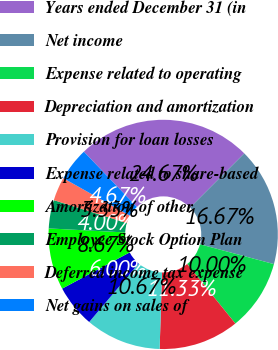Convert chart to OTSL. <chart><loc_0><loc_0><loc_500><loc_500><pie_chart><fcel>Years ended December 31 (in<fcel>Net income<fcel>Expense related to operating<fcel>Depreciation and amortization<fcel>Provision for loan losses<fcel>Expense related to share-based<fcel>Amortization of other<fcel>Employee Stock Option Plan<fcel>Deferred income tax expense<fcel>Net gains on sales of<nl><fcel>24.67%<fcel>16.67%<fcel>10.0%<fcel>11.33%<fcel>10.67%<fcel>6.0%<fcel>8.67%<fcel>4.0%<fcel>3.33%<fcel>4.67%<nl></chart> 